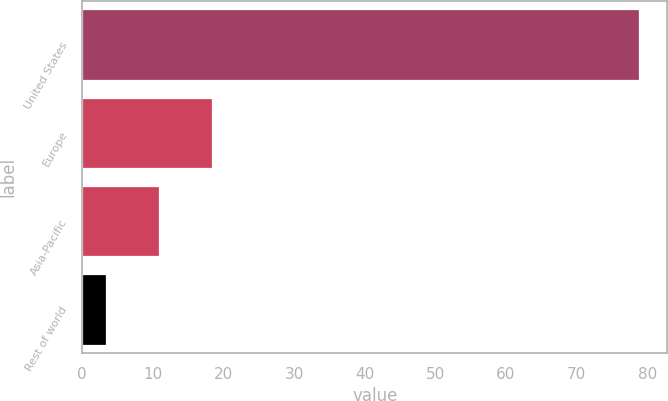Convert chart to OTSL. <chart><loc_0><loc_0><loc_500><loc_500><bar_chart><fcel>United States<fcel>Europe<fcel>Asia-Pacific<fcel>Rest of world<nl><fcel>78.9<fcel>18.42<fcel>10.86<fcel>3.3<nl></chart> 